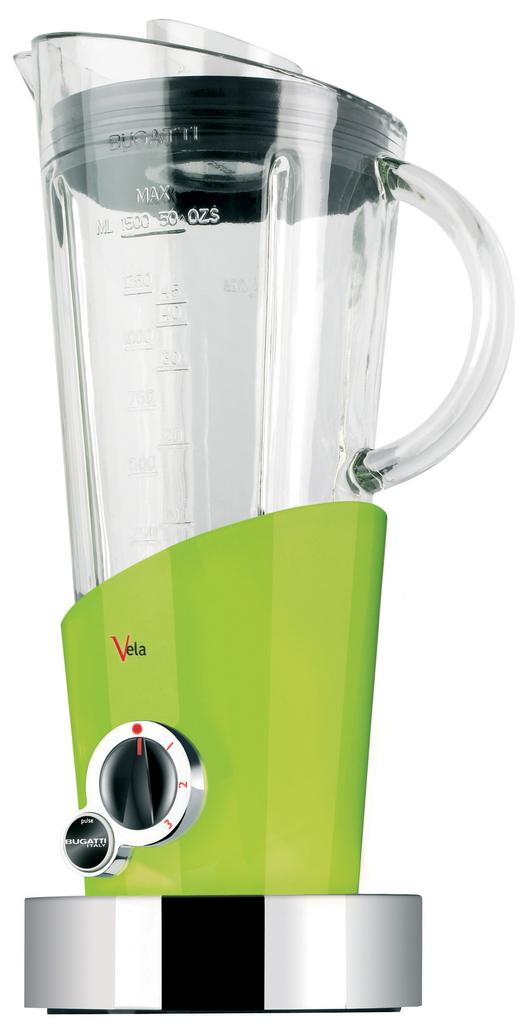Provide a one-sentence caption for the provided image. A blender by the brand name of "Vela" is visible. 